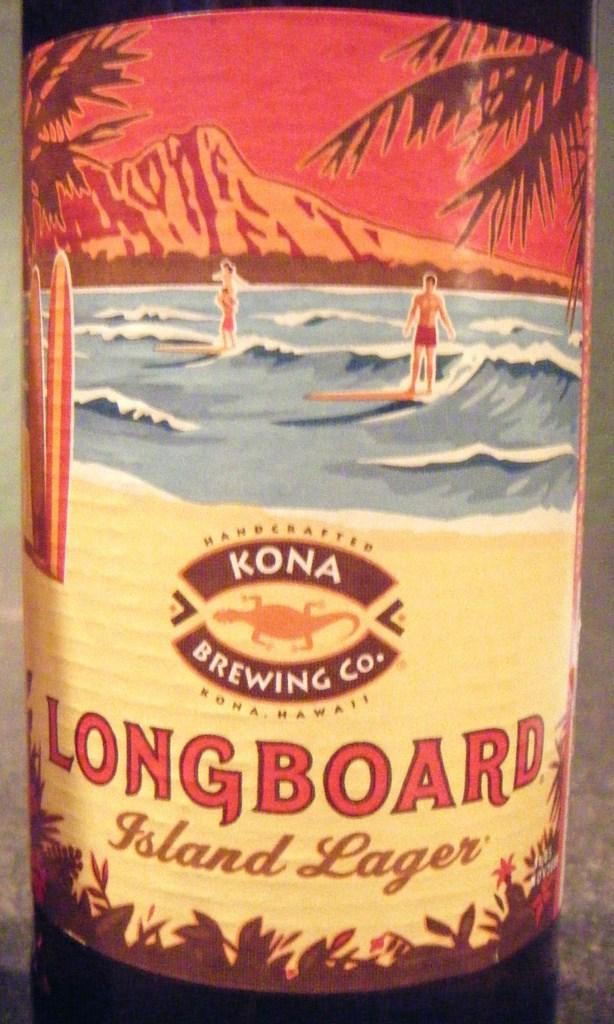What is the company's name?
Give a very brief answer. Kona brewing co. What does it say on the bottle?
Your answer should be compact. Longboard island lager. 